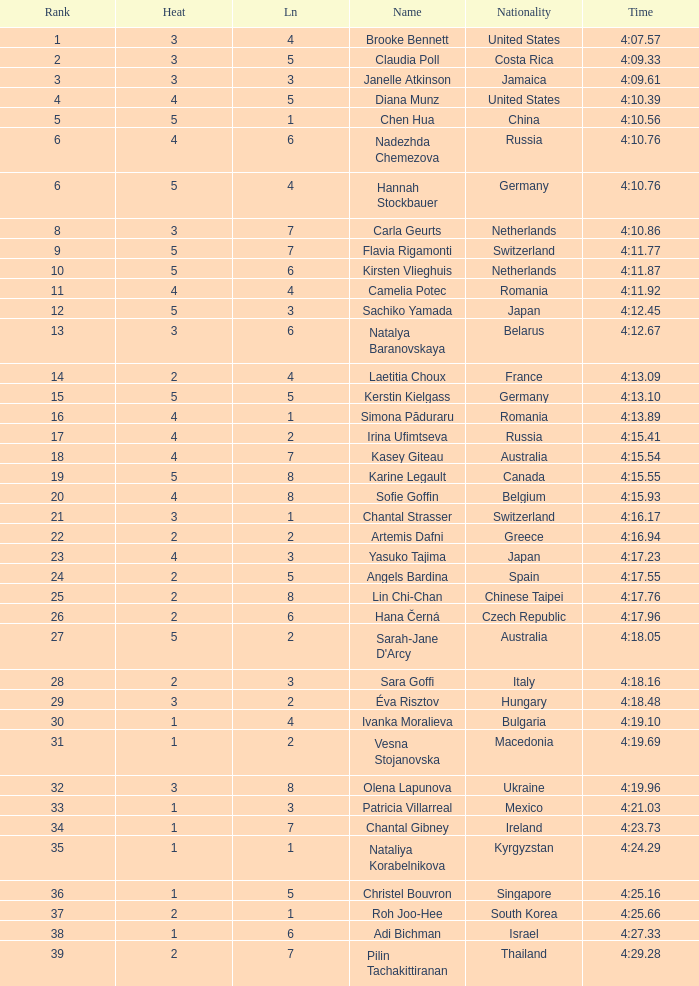Name the average rank with larger than 3 and heat more than 5 None. 